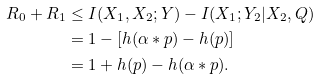<formula> <loc_0><loc_0><loc_500><loc_500>R _ { 0 } + R _ { 1 } & \leq I ( X _ { 1 } , X _ { 2 } ; Y ) - I ( X _ { 1 } ; Y _ { 2 } | X _ { 2 } , Q ) \\ & = 1 - [ h ( \alpha * p ) - h ( p ) ] \\ & = 1 + h ( p ) - h ( \alpha * p ) .</formula> 